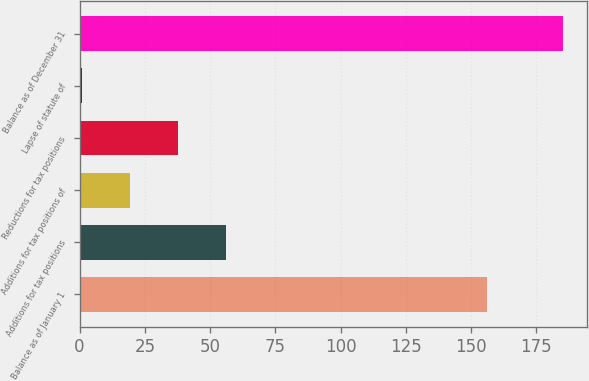Convert chart. <chart><loc_0><loc_0><loc_500><loc_500><bar_chart><fcel>Balance as of January 1<fcel>Additions for tax positions<fcel>Additions for tax positions of<fcel>Reductions for tax positions<fcel>Lapse of statute of<fcel>Balance as of December 31<nl><fcel>156.1<fcel>56.09<fcel>19.23<fcel>37.66<fcel>0.8<fcel>185.1<nl></chart> 